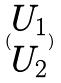<formula> <loc_0><loc_0><loc_500><loc_500>( \begin{matrix} U _ { 1 } \\ U _ { 2 } \end{matrix} )</formula> 